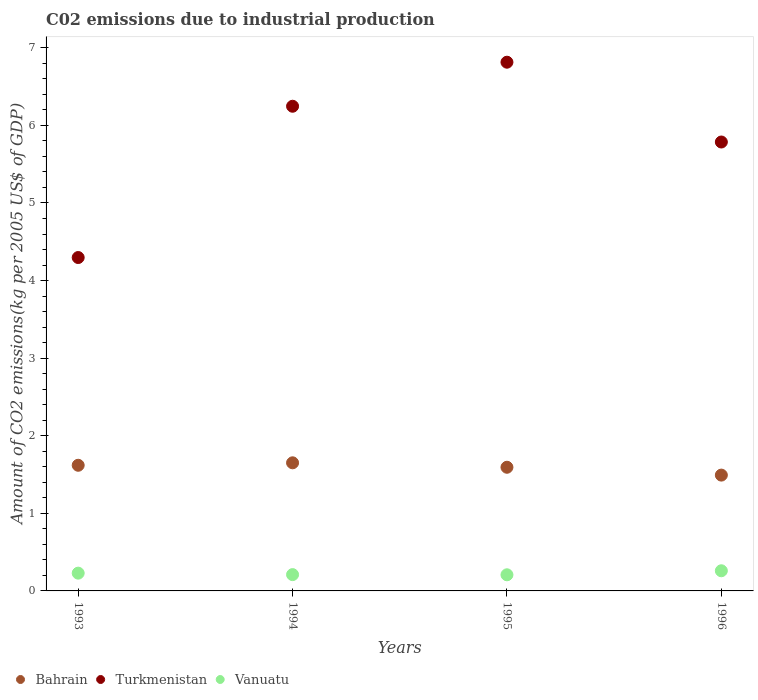Is the number of dotlines equal to the number of legend labels?
Make the answer very short. Yes. What is the amount of CO2 emitted due to industrial production in Turkmenistan in 1994?
Your response must be concise. 6.25. Across all years, what is the maximum amount of CO2 emitted due to industrial production in Bahrain?
Your response must be concise. 1.65. Across all years, what is the minimum amount of CO2 emitted due to industrial production in Turkmenistan?
Offer a very short reply. 4.3. In which year was the amount of CO2 emitted due to industrial production in Vanuatu maximum?
Your answer should be compact. 1996. In which year was the amount of CO2 emitted due to industrial production in Bahrain minimum?
Give a very brief answer. 1996. What is the total amount of CO2 emitted due to industrial production in Bahrain in the graph?
Provide a short and direct response. 6.36. What is the difference between the amount of CO2 emitted due to industrial production in Turkmenistan in 1995 and that in 1996?
Provide a short and direct response. 1.03. What is the difference between the amount of CO2 emitted due to industrial production in Bahrain in 1995 and the amount of CO2 emitted due to industrial production in Vanuatu in 1996?
Your answer should be very brief. 1.33. What is the average amount of CO2 emitted due to industrial production in Turkmenistan per year?
Your answer should be very brief. 5.79. In the year 1994, what is the difference between the amount of CO2 emitted due to industrial production in Vanuatu and amount of CO2 emitted due to industrial production in Turkmenistan?
Provide a succinct answer. -6.04. What is the ratio of the amount of CO2 emitted due to industrial production in Bahrain in 1993 to that in 1995?
Your answer should be compact. 1.02. What is the difference between the highest and the second highest amount of CO2 emitted due to industrial production in Vanuatu?
Give a very brief answer. 0.03. What is the difference between the highest and the lowest amount of CO2 emitted due to industrial production in Turkmenistan?
Your answer should be very brief. 2.52. Is the sum of the amount of CO2 emitted due to industrial production in Bahrain in 1993 and 1996 greater than the maximum amount of CO2 emitted due to industrial production in Vanuatu across all years?
Offer a terse response. Yes. Is it the case that in every year, the sum of the amount of CO2 emitted due to industrial production in Bahrain and amount of CO2 emitted due to industrial production in Vanuatu  is greater than the amount of CO2 emitted due to industrial production in Turkmenistan?
Your answer should be very brief. No. Is the amount of CO2 emitted due to industrial production in Turkmenistan strictly greater than the amount of CO2 emitted due to industrial production in Vanuatu over the years?
Make the answer very short. Yes. Is the amount of CO2 emitted due to industrial production in Turkmenistan strictly less than the amount of CO2 emitted due to industrial production in Bahrain over the years?
Your answer should be compact. No. How many dotlines are there?
Provide a succinct answer. 3. What is the difference between two consecutive major ticks on the Y-axis?
Provide a short and direct response. 1. Does the graph contain grids?
Make the answer very short. No. Where does the legend appear in the graph?
Your response must be concise. Bottom left. What is the title of the graph?
Your response must be concise. C02 emissions due to industrial production. What is the label or title of the Y-axis?
Ensure brevity in your answer.  Amount of CO2 emissions(kg per 2005 US$ of GDP). What is the Amount of CO2 emissions(kg per 2005 US$ of GDP) of Bahrain in 1993?
Offer a very short reply. 1.62. What is the Amount of CO2 emissions(kg per 2005 US$ of GDP) in Turkmenistan in 1993?
Ensure brevity in your answer.  4.3. What is the Amount of CO2 emissions(kg per 2005 US$ of GDP) in Vanuatu in 1993?
Make the answer very short. 0.23. What is the Amount of CO2 emissions(kg per 2005 US$ of GDP) of Bahrain in 1994?
Make the answer very short. 1.65. What is the Amount of CO2 emissions(kg per 2005 US$ of GDP) in Turkmenistan in 1994?
Offer a very short reply. 6.25. What is the Amount of CO2 emissions(kg per 2005 US$ of GDP) in Vanuatu in 1994?
Offer a very short reply. 0.21. What is the Amount of CO2 emissions(kg per 2005 US$ of GDP) in Bahrain in 1995?
Offer a very short reply. 1.59. What is the Amount of CO2 emissions(kg per 2005 US$ of GDP) in Turkmenistan in 1995?
Give a very brief answer. 6.81. What is the Amount of CO2 emissions(kg per 2005 US$ of GDP) in Vanuatu in 1995?
Provide a short and direct response. 0.21. What is the Amount of CO2 emissions(kg per 2005 US$ of GDP) of Bahrain in 1996?
Provide a short and direct response. 1.49. What is the Amount of CO2 emissions(kg per 2005 US$ of GDP) of Turkmenistan in 1996?
Offer a terse response. 5.79. What is the Amount of CO2 emissions(kg per 2005 US$ of GDP) in Vanuatu in 1996?
Offer a very short reply. 0.26. Across all years, what is the maximum Amount of CO2 emissions(kg per 2005 US$ of GDP) of Bahrain?
Give a very brief answer. 1.65. Across all years, what is the maximum Amount of CO2 emissions(kg per 2005 US$ of GDP) in Turkmenistan?
Ensure brevity in your answer.  6.81. Across all years, what is the maximum Amount of CO2 emissions(kg per 2005 US$ of GDP) of Vanuatu?
Provide a short and direct response. 0.26. Across all years, what is the minimum Amount of CO2 emissions(kg per 2005 US$ of GDP) of Bahrain?
Keep it short and to the point. 1.49. Across all years, what is the minimum Amount of CO2 emissions(kg per 2005 US$ of GDP) in Turkmenistan?
Provide a succinct answer. 4.3. Across all years, what is the minimum Amount of CO2 emissions(kg per 2005 US$ of GDP) in Vanuatu?
Keep it short and to the point. 0.21. What is the total Amount of CO2 emissions(kg per 2005 US$ of GDP) in Bahrain in the graph?
Offer a very short reply. 6.36. What is the total Amount of CO2 emissions(kg per 2005 US$ of GDP) of Turkmenistan in the graph?
Your answer should be compact. 23.14. What is the total Amount of CO2 emissions(kg per 2005 US$ of GDP) of Vanuatu in the graph?
Your answer should be compact. 0.91. What is the difference between the Amount of CO2 emissions(kg per 2005 US$ of GDP) in Bahrain in 1993 and that in 1994?
Provide a succinct answer. -0.03. What is the difference between the Amount of CO2 emissions(kg per 2005 US$ of GDP) in Turkmenistan in 1993 and that in 1994?
Provide a succinct answer. -1.95. What is the difference between the Amount of CO2 emissions(kg per 2005 US$ of GDP) in Vanuatu in 1993 and that in 1994?
Give a very brief answer. 0.02. What is the difference between the Amount of CO2 emissions(kg per 2005 US$ of GDP) of Bahrain in 1993 and that in 1995?
Ensure brevity in your answer.  0.03. What is the difference between the Amount of CO2 emissions(kg per 2005 US$ of GDP) in Turkmenistan in 1993 and that in 1995?
Keep it short and to the point. -2.52. What is the difference between the Amount of CO2 emissions(kg per 2005 US$ of GDP) in Vanuatu in 1993 and that in 1995?
Your response must be concise. 0.02. What is the difference between the Amount of CO2 emissions(kg per 2005 US$ of GDP) of Bahrain in 1993 and that in 1996?
Your answer should be compact. 0.13. What is the difference between the Amount of CO2 emissions(kg per 2005 US$ of GDP) of Turkmenistan in 1993 and that in 1996?
Provide a short and direct response. -1.49. What is the difference between the Amount of CO2 emissions(kg per 2005 US$ of GDP) in Vanuatu in 1993 and that in 1996?
Offer a terse response. -0.03. What is the difference between the Amount of CO2 emissions(kg per 2005 US$ of GDP) of Bahrain in 1994 and that in 1995?
Make the answer very short. 0.06. What is the difference between the Amount of CO2 emissions(kg per 2005 US$ of GDP) in Turkmenistan in 1994 and that in 1995?
Make the answer very short. -0.57. What is the difference between the Amount of CO2 emissions(kg per 2005 US$ of GDP) in Vanuatu in 1994 and that in 1995?
Keep it short and to the point. 0. What is the difference between the Amount of CO2 emissions(kg per 2005 US$ of GDP) in Bahrain in 1994 and that in 1996?
Provide a short and direct response. 0.16. What is the difference between the Amount of CO2 emissions(kg per 2005 US$ of GDP) in Turkmenistan in 1994 and that in 1996?
Offer a terse response. 0.46. What is the difference between the Amount of CO2 emissions(kg per 2005 US$ of GDP) in Vanuatu in 1994 and that in 1996?
Provide a succinct answer. -0.05. What is the difference between the Amount of CO2 emissions(kg per 2005 US$ of GDP) in Bahrain in 1995 and that in 1996?
Offer a very short reply. 0.1. What is the difference between the Amount of CO2 emissions(kg per 2005 US$ of GDP) of Turkmenistan in 1995 and that in 1996?
Ensure brevity in your answer.  1.03. What is the difference between the Amount of CO2 emissions(kg per 2005 US$ of GDP) in Vanuatu in 1995 and that in 1996?
Give a very brief answer. -0.05. What is the difference between the Amount of CO2 emissions(kg per 2005 US$ of GDP) of Bahrain in 1993 and the Amount of CO2 emissions(kg per 2005 US$ of GDP) of Turkmenistan in 1994?
Your response must be concise. -4.63. What is the difference between the Amount of CO2 emissions(kg per 2005 US$ of GDP) of Bahrain in 1993 and the Amount of CO2 emissions(kg per 2005 US$ of GDP) of Vanuatu in 1994?
Your answer should be very brief. 1.41. What is the difference between the Amount of CO2 emissions(kg per 2005 US$ of GDP) in Turkmenistan in 1993 and the Amount of CO2 emissions(kg per 2005 US$ of GDP) in Vanuatu in 1994?
Your response must be concise. 4.09. What is the difference between the Amount of CO2 emissions(kg per 2005 US$ of GDP) in Bahrain in 1993 and the Amount of CO2 emissions(kg per 2005 US$ of GDP) in Turkmenistan in 1995?
Make the answer very short. -5.2. What is the difference between the Amount of CO2 emissions(kg per 2005 US$ of GDP) of Bahrain in 1993 and the Amount of CO2 emissions(kg per 2005 US$ of GDP) of Vanuatu in 1995?
Provide a succinct answer. 1.41. What is the difference between the Amount of CO2 emissions(kg per 2005 US$ of GDP) of Turkmenistan in 1993 and the Amount of CO2 emissions(kg per 2005 US$ of GDP) of Vanuatu in 1995?
Provide a succinct answer. 4.09. What is the difference between the Amount of CO2 emissions(kg per 2005 US$ of GDP) in Bahrain in 1993 and the Amount of CO2 emissions(kg per 2005 US$ of GDP) in Turkmenistan in 1996?
Offer a very short reply. -4.17. What is the difference between the Amount of CO2 emissions(kg per 2005 US$ of GDP) of Bahrain in 1993 and the Amount of CO2 emissions(kg per 2005 US$ of GDP) of Vanuatu in 1996?
Give a very brief answer. 1.36. What is the difference between the Amount of CO2 emissions(kg per 2005 US$ of GDP) of Turkmenistan in 1993 and the Amount of CO2 emissions(kg per 2005 US$ of GDP) of Vanuatu in 1996?
Offer a very short reply. 4.04. What is the difference between the Amount of CO2 emissions(kg per 2005 US$ of GDP) in Bahrain in 1994 and the Amount of CO2 emissions(kg per 2005 US$ of GDP) in Turkmenistan in 1995?
Offer a terse response. -5.16. What is the difference between the Amount of CO2 emissions(kg per 2005 US$ of GDP) in Bahrain in 1994 and the Amount of CO2 emissions(kg per 2005 US$ of GDP) in Vanuatu in 1995?
Keep it short and to the point. 1.44. What is the difference between the Amount of CO2 emissions(kg per 2005 US$ of GDP) of Turkmenistan in 1994 and the Amount of CO2 emissions(kg per 2005 US$ of GDP) of Vanuatu in 1995?
Provide a short and direct response. 6.04. What is the difference between the Amount of CO2 emissions(kg per 2005 US$ of GDP) of Bahrain in 1994 and the Amount of CO2 emissions(kg per 2005 US$ of GDP) of Turkmenistan in 1996?
Provide a succinct answer. -4.13. What is the difference between the Amount of CO2 emissions(kg per 2005 US$ of GDP) in Bahrain in 1994 and the Amount of CO2 emissions(kg per 2005 US$ of GDP) in Vanuatu in 1996?
Your response must be concise. 1.39. What is the difference between the Amount of CO2 emissions(kg per 2005 US$ of GDP) in Turkmenistan in 1994 and the Amount of CO2 emissions(kg per 2005 US$ of GDP) in Vanuatu in 1996?
Provide a succinct answer. 5.99. What is the difference between the Amount of CO2 emissions(kg per 2005 US$ of GDP) in Bahrain in 1995 and the Amount of CO2 emissions(kg per 2005 US$ of GDP) in Turkmenistan in 1996?
Offer a terse response. -4.19. What is the difference between the Amount of CO2 emissions(kg per 2005 US$ of GDP) of Bahrain in 1995 and the Amount of CO2 emissions(kg per 2005 US$ of GDP) of Vanuatu in 1996?
Provide a succinct answer. 1.33. What is the difference between the Amount of CO2 emissions(kg per 2005 US$ of GDP) of Turkmenistan in 1995 and the Amount of CO2 emissions(kg per 2005 US$ of GDP) of Vanuatu in 1996?
Offer a very short reply. 6.55. What is the average Amount of CO2 emissions(kg per 2005 US$ of GDP) in Bahrain per year?
Keep it short and to the point. 1.59. What is the average Amount of CO2 emissions(kg per 2005 US$ of GDP) in Turkmenistan per year?
Offer a very short reply. 5.79. What is the average Amount of CO2 emissions(kg per 2005 US$ of GDP) of Vanuatu per year?
Your answer should be very brief. 0.23. In the year 1993, what is the difference between the Amount of CO2 emissions(kg per 2005 US$ of GDP) in Bahrain and Amount of CO2 emissions(kg per 2005 US$ of GDP) in Turkmenistan?
Your answer should be very brief. -2.68. In the year 1993, what is the difference between the Amount of CO2 emissions(kg per 2005 US$ of GDP) in Bahrain and Amount of CO2 emissions(kg per 2005 US$ of GDP) in Vanuatu?
Give a very brief answer. 1.39. In the year 1993, what is the difference between the Amount of CO2 emissions(kg per 2005 US$ of GDP) of Turkmenistan and Amount of CO2 emissions(kg per 2005 US$ of GDP) of Vanuatu?
Offer a very short reply. 4.07. In the year 1994, what is the difference between the Amount of CO2 emissions(kg per 2005 US$ of GDP) in Bahrain and Amount of CO2 emissions(kg per 2005 US$ of GDP) in Turkmenistan?
Make the answer very short. -4.6. In the year 1994, what is the difference between the Amount of CO2 emissions(kg per 2005 US$ of GDP) in Bahrain and Amount of CO2 emissions(kg per 2005 US$ of GDP) in Vanuatu?
Give a very brief answer. 1.44. In the year 1994, what is the difference between the Amount of CO2 emissions(kg per 2005 US$ of GDP) of Turkmenistan and Amount of CO2 emissions(kg per 2005 US$ of GDP) of Vanuatu?
Offer a terse response. 6.04. In the year 1995, what is the difference between the Amount of CO2 emissions(kg per 2005 US$ of GDP) in Bahrain and Amount of CO2 emissions(kg per 2005 US$ of GDP) in Turkmenistan?
Provide a succinct answer. -5.22. In the year 1995, what is the difference between the Amount of CO2 emissions(kg per 2005 US$ of GDP) in Bahrain and Amount of CO2 emissions(kg per 2005 US$ of GDP) in Vanuatu?
Offer a very short reply. 1.39. In the year 1995, what is the difference between the Amount of CO2 emissions(kg per 2005 US$ of GDP) in Turkmenistan and Amount of CO2 emissions(kg per 2005 US$ of GDP) in Vanuatu?
Your answer should be compact. 6.61. In the year 1996, what is the difference between the Amount of CO2 emissions(kg per 2005 US$ of GDP) in Bahrain and Amount of CO2 emissions(kg per 2005 US$ of GDP) in Turkmenistan?
Your response must be concise. -4.29. In the year 1996, what is the difference between the Amount of CO2 emissions(kg per 2005 US$ of GDP) in Bahrain and Amount of CO2 emissions(kg per 2005 US$ of GDP) in Vanuatu?
Provide a short and direct response. 1.23. In the year 1996, what is the difference between the Amount of CO2 emissions(kg per 2005 US$ of GDP) in Turkmenistan and Amount of CO2 emissions(kg per 2005 US$ of GDP) in Vanuatu?
Your answer should be very brief. 5.53. What is the ratio of the Amount of CO2 emissions(kg per 2005 US$ of GDP) in Bahrain in 1993 to that in 1994?
Offer a very short reply. 0.98. What is the ratio of the Amount of CO2 emissions(kg per 2005 US$ of GDP) in Turkmenistan in 1993 to that in 1994?
Ensure brevity in your answer.  0.69. What is the ratio of the Amount of CO2 emissions(kg per 2005 US$ of GDP) of Vanuatu in 1993 to that in 1994?
Offer a terse response. 1.09. What is the ratio of the Amount of CO2 emissions(kg per 2005 US$ of GDP) of Bahrain in 1993 to that in 1995?
Make the answer very short. 1.02. What is the ratio of the Amount of CO2 emissions(kg per 2005 US$ of GDP) of Turkmenistan in 1993 to that in 1995?
Your answer should be compact. 0.63. What is the ratio of the Amount of CO2 emissions(kg per 2005 US$ of GDP) in Vanuatu in 1993 to that in 1995?
Your response must be concise. 1.1. What is the ratio of the Amount of CO2 emissions(kg per 2005 US$ of GDP) of Bahrain in 1993 to that in 1996?
Keep it short and to the point. 1.08. What is the ratio of the Amount of CO2 emissions(kg per 2005 US$ of GDP) in Turkmenistan in 1993 to that in 1996?
Ensure brevity in your answer.  0.74. What is the ratio of the Amount of CO2 emissions(kg per 2005 US$ of GDP) of Vanuatu in 1993 to that in 1996?
Offer a very short reply. 0.88. What is the ratio of the Amount of CO2 emissions(kg per 2005 US$ of GDP) in Bahrain in 1994 to that in 1995?
Provide a short and direct response. 1.04. What is the ratio of the Amount of CO2 emissions(kg per 2005 US$ of GDP) of Bahrain in 1994 to that in 1996?
Keep it short and to the point. 1.11. What is the ratio of the Amount of CO2 emissions(kg per 2005 US$ of GDP) of Turkmenistan in 1994 to that in 1996?
Offer a terse response. 1.08. What is the ratio of the Amount of CO2 emissions(kg per 2005 US$ of GDP) of Vanuatu in 1994 to that in 1996?
Make the answer very short. 0.81. What is the ratio of the Amount of CO2 emissions(kg per 2005 US$ of GDP) of Bahrain in 1995 to that in 1996?
Offer a terse response. 1.07. What is the ratio of the Amount of CO2 emissions(kg per 2005 US$ of GDP) of Turkmenistan in 1995 to that in 1996?
Offer a terse response. 1.18. What is the ratio of the Amount of CO2 emissions(kg per 2005 US$ of GDP) in Vanuatu in 1995 to that in 1996?
Your answer should be compact. 0.8. What is the difference between the highest and the second highest Amount of CO2 emissions(kg per 2005 US$ of GDP) of Bahrain?
Provide a succinct answer. 0.03. What is the difference between the highest and the second highest Amount of CO2 emissions(kg per 2005 US$ of GDP) of Turkmenistan?
Make the answer very short. 0.57. What is the difference between the highest and the second highest Amount of CO2 emissions(kg per 2005 US$ of GDP) of Vanuatu?
Provide a short and direct response. 0.03. What is the difference between the highest and the lowest Amount of CO2 emissions(kg per 2005 US$ of GDP) of Bahrain?
Give a very brief answer. 0.16. What is the difference between the highest and the lowest Amount of CO2 emissions(kg per 2005 US$ of GDP) of Turkmenistan?
Provide a short and direct response. 2.52. What is the difference between the highest and the lowest Amount of CO2 emissions(kg per 2005 US$ of GDP) in Vanuatu?
Offer a very short reply. 0.05. 